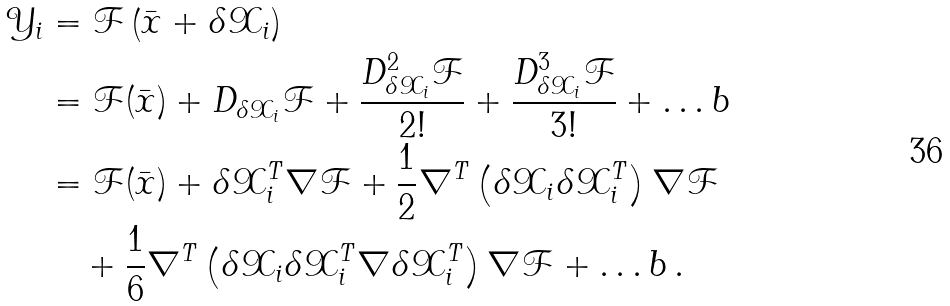<formula> <loc_0><loc_0><loc_500><loc_500>\mathcal { Y } _ { i } & = \mathcal { F } \left ( \bar { x } + \delta \mathcal { X } _ { i } \right ) \\ & = \mathcal { F } ( \bar { x } ) + D _ { \delta \mathcal { X } _ { i } } \mathcal { F } + \frac { D _ { \delta \mathcal { X } _ { i } } ^ { 2 } \mathcal { F } } { 2 ! } + \frac { D _ { \delta \mathcal { X } _ { i } } ^ { 3 } \mathcal { F } } { 3 ! } + \dots b \\ & = \mathcal { F } ( \bar { x } ) + \delta \mathcal { X } _ { i } ^ { T } \nabla \mathcal { F } + \frac { 1 } { 2 } \nabla ^ { T } \left ( \delta \mathcal { X } _ { i } \delta \mathcal { X } _ { i } ^ { T } \right ) \nabla \mathcal { F } \\ & \quad + \frac { 1 } { 6 } \nabla ^ { T } \left ( \delta \mathcal { X } _ { i } \delta \mathcal { X } _ { i } ^ { T } \nabla \delta \mathcal { X } _ { i } ^ { T } \right ) \nabla \mathcal { F } + \dots b \, .</formula> 